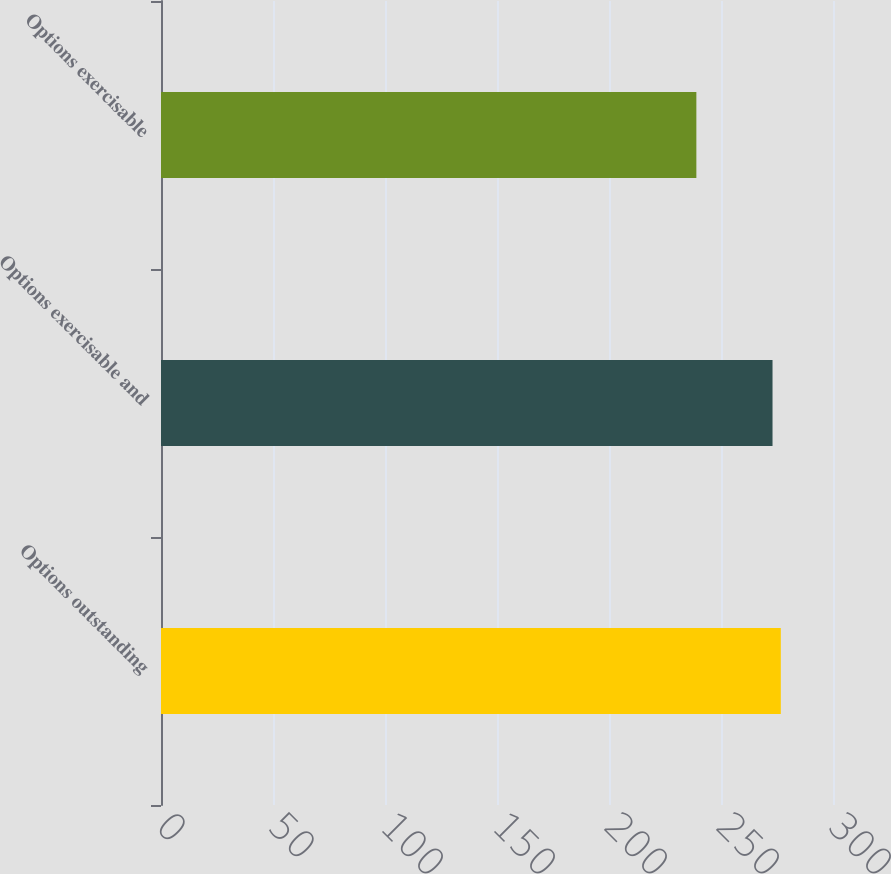<chart> <loc_0><loc_0><loc_500><loc_500><bar_chart><fcel>Options outstanding<fcel>Options exercisable and<fcel>Options exercisable<nl><fcel>276.7<fcel>273<fcel>239<nl></chart> 